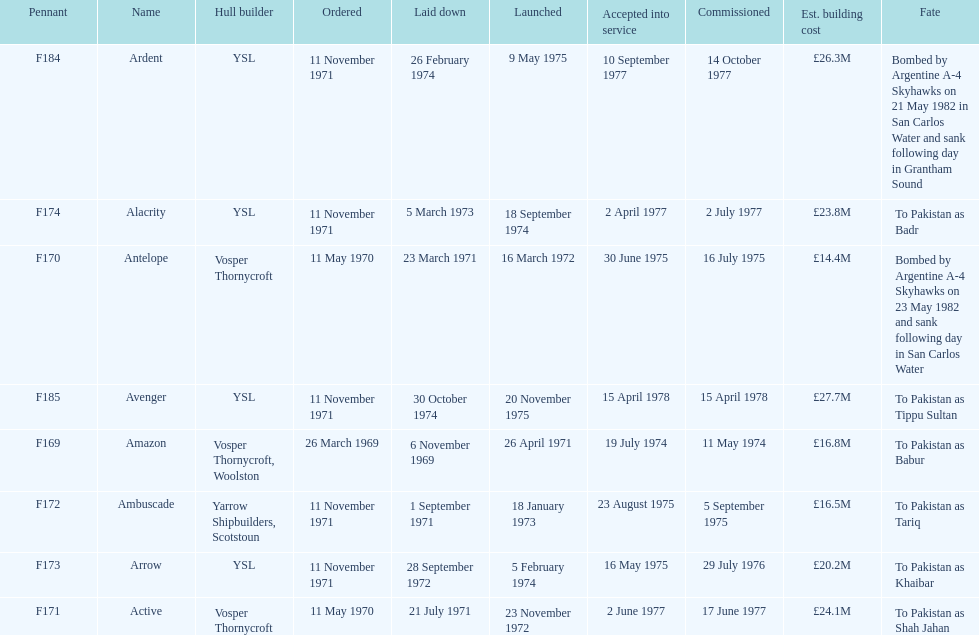The arrow was ordered on november 11, 1971. what was the previous ship? Ambuscade. 